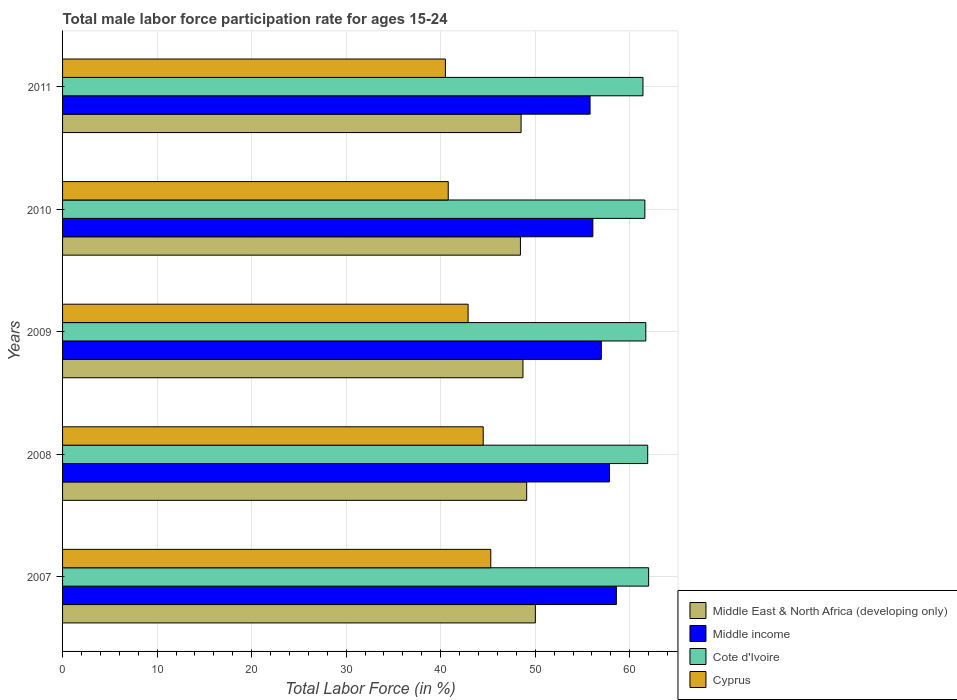Are the number of bars per tick equal to the number of legend labels?
Your answer should be compact. Yes. How many bars are there on the 5th tick from the top?
Give a very brief answer. 4. How many bars are there on the 1st tick from the bottom?
Keep it short and to the point. 4. What is the label of the 5th group of bars from the top?
Make the answer very short. 2007. What is the male labor force participation rate in Cote d'Ivoire in 2008?
Provide a succinct answer. 61.9. Across all years, what is the maximum male labor force participation rate in Middle income?
Ensure brevity in your answer.  58.58. Across all years, what is the minimum male labor force participation rate in Middle income?
Your answer should be compact. 55.8. What is the total male labor force participation rate in Cote d'Ivoire in the graph?
Your answer should be compact. 308.6. What is the difference between the male labor force participation rate in Cyprus in 2009 and that in 2010?
Offer a terse response. 2.1. What is the difference between the male labor force participation rate in Cote d'Ivoire in 2009 and the male labor force participation rate in Cyprus in 2007?
Make the answer very short. 16.4. What is the average male labor force participation rate in Cote d'Ivoire per year?
Your answer should be compact. 61.72. In the year 2007, what is the difference between the male labor force participation rate in Middle East & North Africa (developing only) and male labor force participation rate in Cyprus?
Provide a short and direct response. 4.72. In how many years, is the male labor force participation rate in Cyprus greater than 32 %?
Your response must be concise. 5. What is the ratio of the male labor force participation rate in Cote d'Ivoire in 2007 to that in 2009?
Ensure brevity in your answer.  1. Is the male labor force participation rate in Cyprus in 2007 less than that in 2011?
Offer a terse response. No. What is the difference between the highest and the second highest male labor force participation rate in Cyprus?
Offer a very short reply. 0.8. What is the difference between the highest and the lowest male labor force participation rate in Middle income?
Your response must be concise. 2.78. In how many years, is the male labor force participation rate in Cyprus greater than the average male labor force participation rate in Cyprus taken over all years?
Provide a succinct answer. 3. What does the 4th bar from the top in 2007 represents?
Ensure brevity in your answer.  Middle East & North Africa (developing only). What does the 2nd bar from the bottom in 2010 represents?
Give a very brief answer. Middle income. How many bars are there?
Your answer should be very brief. 20. Are all the bars in the graph horizontal?
Ensure brevity in your answer.  Yes. How many years are there in the graph?
Offer a very short reply. 5. What is the difference between two consecutive major ticks on the X-axis?
Make the answer very short. 10. Where does the legend appear in the graph?
Your answer should be very brief. Bottom right. How are the legend labels stacked?
Your answer should be very brief. Vertical. What is the title of the graph?
Ensure brevity in your answer.  Total male labor force participation rate for ages 15-24. Does "Romania" appear as one of the legend labels in the graph?
Offer a terse response. No. What is the label or title of the X-axis?
Ensure brevity in your answer.  Total Labor Force (in %). What is the label or title of the Y-axis?
Provide a succinct answer. Years. What is the Total Labor Force (in %) of Middle East & North Africa (developing only) in 2007?
Make the answer very short. 50.02. What is the Total Labor Force (in %) in Middle income in 2007?
Provide a short and direct response. 58.58. What is the Total Labor Force (in %) in Cote d'Ivoire in 2007?
Your answer should be compact. 62. What is the Total Labor Force (in %) of Cyprus in 2007?
Provide a succinct answer. 45.3. What is the Total Labor Force (in %) of Middle East & North Africa (developing only) in 2008?
Your response must be concise. 49.1. What is the Total Labor Force (in %) in Middle income in 2008?
Offer a terse response. 57.85. What is the Total Labor Force (in %) in Cote d'Ivoire in 2008?
Your response must be concise. 61.9. What is the Total Labor Force (in %) of Cyprus in 2008?
Your response must be concise. 44.5. What is the Total Labor Force (in %) of Middle East & North Africa (developing only) in 2009?
Give a very brief answer. 48.7. What is the Total Labor Force (in %) of Middle income in 2009?
Ensure brevity in your answer.  56.99. What is the Total Labor Force (in %) in Cote d'Ivoire in 2009?
Provide a short and direct response. 61.7. What is the Total Labor Force (in %) in Cyprus in 2009?
Provide a short and direct response. 42.9. What is the Total Labor Force (in %) in Middle East & North Africa (developing only) in 2010?
Keep it short and to the point. 48.44. What is the Total Labor Force (in %) of Middle income in 2010?
Provide a succinct answer. 56.1. What is the Total Labor Force (in %) of Cote d'Ivoire in 2010?
Your answer should be compact. 61.6. What is the Total Labor Force (in %) of Cyprus in 2010?
Provide a succinct answer. 40.8. What is the Total Labor Force (in %) in Middle East & North Africa (developing only) in 2011?
Make the answer very short. 48.51. What is the Total Labor Force (in %) in Middle income in 2011?
Your answer should be compact. 55.8. What is the Total Labor Force (in %) in Cote d'Ivoire in 2011?
Give a very brief answer. 61.4. What is the Total Labor Force (in %) of Cyprus in 2011?
Provide a short and direct response. 40.5. Across all years, what is the maximum Total Labor Force (in %) of Middle East & North Africa (developing only)?
Keep it short and to the point. 50.02. Across all years, what is the maximum Total Labor Force (in %) of Middle income?
Your response must be concise. 58.58. Across all years, what is the maximum Total Labor Force (in %) in Cyprus?
Provide a succinct answer. 45.3. Across all years, what is the minimum Total Labor Force (in %) of Middle East & North Africa (developing only)?
Ensure brevity in your answer.  48.44. Across all years, what is the minimum Total Labor Force (in %) of Middle income?
Make the answer very short. 55.8. Across all years, what is the minimum Total Labor Force (in %) of Cote d'Ivoire?
Offer a very short reply. 61.4. Across all years, what is the minimum Total Labor Force (in %) in Cyprus?
Your answer should be compact. 40.5. What is the total Total Labor Force (in %) of Middle East & North Africa (developing only) in the graph?
Offer a very short reply. 244.76. What is the total Total Labor Force (in %) of Middle income in the graph?
Ensure brevity in your answer.  285.32. What is the total Total Labor Force (in %) of Cote d'Ivoire in the graph?
Keep it short and to the point. 308.6. What is the total Total Labor Force (in %) in Cyprus in the graph?
Provide a succinct answer. 214. What is the difference between the Total Labor Force (in %) of Middle income in 2007 and that in 2008?
Your response must be concise. 0.74. What is the difference between the Total Labor Force (in %) in Middle East & North Africa (developing only) in 2007 and that in 2009?
Provide a short and direct response. 1.31. What is the difference between the Total Labor Force (in %) of Middle income in 2007 and that in 2009?
Offer a terse response. 1.59. What is the difference between the Total Labor Force (in %) in Cote d'Ivoire in 2007 and that in 2009?
Your answer should be compact. 0.3. What is the difference between the Total Labor Force (in %) of Middle East & North Africa (developing only) in 2007 and that in 2010?
Make the answer very short. 1.58. What is the difference between the Total Labor Force (in %) of Middle income in 2007 and that in 2010?
Ensure brevity in your answer.  2.49. What is the difference between the Total Labor Force (in %) of Middle East & North Africa (developing only) in 2007 and that in 2011?
Provide a succinct answer. 1.51. What is the difference between the Total Labor Force (in %) of Middle income in 2007 and that in 2011?
Make the answer very short. 2.78. What is the difference between the Total Labor Force (in %) of Cote d'Ivoire in 2007 and that in 2011?
Offer a terse response. 0.6. What is the difference between the Total Labor Force (in %) in Cyprus in 2007 and that in 2011?
Give a very brief answer. 4.8. What is the difference between the Total Labor Force (in %) in Middle East & North Africa (developing only) in 2008 and that in 2009?
Offer a terse response. 0.4. What is the difference between the Total Labor Force (in %) of Middle income in 2008 and that in 2009?
Provide a short and direct response. 0.85. What is the difference between the Total Labor Force (in %) in Middle East & North Africa (developing only) in 2008 and that in 2010?
Provide a short and direct response. 0.66. What is the difference between the Total Labor Force (in %) of Middle income in 2008 and that in 2010?
Offer a terse response. 1.75. What is the difference between the Total Labor Force (in %) in Cote d'Ivoire in 2008 and that in 2010?
Your answer should be very brief. 0.3. What is the difference between the Total Labor Force (in %) of Cyprus in 2008 and that in 2010?
Your response must be concise. 3.7. What is the difference between the Total Labor Force (in %) of Middle East & North Africa (developing only) in 2008 and that in 2011?
Your answer should be compact. 0.59. What is the difference between the Total Labor Force (in %) of Middle income in 2008 and that in 2011?
Your answer should be compact. 2.04. What is the difference between the Total Labor Force (in %) of Cyprus in 2008 and that in 2011?
Ensure brevity in your answer.  4. What is the difference between the Total Labor Force (in %) of Middle East & North Africa (developing only) in 2009 and that in 2010?
Give a very brief answer. 0.27. What is the difference between the Total Labor Force (in %) of Middle income in 2009 and that in 2010?
Provide a short and direct response. 0.89. What is the difference between the Total Labor Force (in %) of Cote d'Ivoire in 2009 and that in 2010?
Make the answer very short. 0.1. What is the difference between the Total Labor Force (in %) of Cyprus in 2009 and that in 2010?
Provide a short and direct response. 2.1. What is the difference between the Total Labor Force (in %) in Middle East & North Africa (developing only) in 2009 and that in 2011?
Ensure brevity in your answer.  0.2. What is the difference between the Total Labor Force (in %) in Middle income in 2009 and that in 2011?
Give a very brief answer. 1.19. What is the difference between the Total Labor Force (in %) in Cyprus in 2009 and that in 2011?
Your answer should be very brief. 2.4. What is the difference between the Total Labor Force (in %) in Middle East & North Africa (developing only) in 2010 and that in 2011?
Your answer should be compact. -0.07. What is the difference between the Total Labor Force (in %) in Middle income in 2010 and that in 2011?
Provide a succinct answer. 0.3. What is the difference between the Total Labor Force (in %) of Middle East & North Africa (developing only) in 2007 and the Total Labor Force (in %) of Middle income in 2008?
Offer a terse response. -7.83. What is the difference between the Total Labor Force (in %) of Middle East & North Africa (developing only) in 2007 and the Total Labor Force (in %) of Cote d'Ivoire in 2008?
Ensure brevity in your answer.  -11.88. What is the difference between the Total Labor Force (in %) of Middle East & North Africa (developing only) in 2007 and the Total Labor Force (in %) of Cyprus in 2008?
Provide a short and direct response. 5.52. What is the difference between the Total Labor Force (in %) of Middle income in 2007 and the Total Labor Force (in %) of Cote d'Ivoire in 2008?
Offer a terse response. -3.32. What is the difference between the Total Labor Force (in %) of Middle income in 2007 and the Total Labor Force (in %) of Cyprus in 2008?
Ensure brevity in your answer.  14.08. What is the difference between the Total Labor Force (in %) in Middle East & North Africa (developing only) in 2007 and the Total Labor Force (in %) in Middle income in 2009?
Offer a terse response. -6.98. What is the difference between the Total Labor Force (in %) of Middle East & North Africa (developing only) in 2007 and the Total Labor Force (in %) of Cote d'Ivoire in 2009?
Give a very brief answer. -11.68. What is the difference between the Total Labor Force (in %) of Middle East & North Africa (developing only) in 2007 and the Total Labor Force (in %) of Cyprus in 2009?
Your response must be concise. 7.12. What is the difference between the Total Labor Force (in %) in Middle income in 2007 and the Total Labor Force (in %) in Cote d'Ivoire in 2009?
Keep it short and to the point. -3.12. What is the difference between the Total Labor Force (in %) in Middle income in 2007 and the Total Labor Force (in %) in Cyprus in 2009?
Your answer should be very brief. 15.68. What is the difference between the Total Labor Force (in %) of Cote d'Ivoire in 2007 and the Total Labor Force (in %) of Cyprus in 2009?
Provide a short and direct response. 19.1. What is the difference between the Total Labor Force (in %) in Middle East & North Africa (developing only) in 2007 and the Total Labor Force (in %) in Middle income in 2010?
Make the answer very short. -6.08. What is the difference between the Total Labor Force (in %) of Middle East & North Africa (developing only) in 2007 and the Total Labor Force (in %) of Cote d'Ivoire in 2010?
Provide a succinct answer. -11.58. What is the difference between the Total Labor Force (in %) of Middle East & North Africa (developing only) in 2007 and the Total Labor Force (in %) of Cyprus in 2010?
Offer a terse response. 9.22. What is the difference between the Total Labor Force (in %) of Middle income in 2007 and the Total Labor Force (in %) of Cote d'Ivoire in 2010?
Offer a terse response. -3.02. What is the difference between the Total Labor Force (in %) of Middle income in 2007 and the Total Labor Force (in %) of Cyprus in 2010?
Provide a short and direct response. 17.78. What is the difference between the Total Labor Force (in %) in Cote d'Ivoire in 2007 and the Total Labor Force (in %) in Cyprus in 2010?
Give a very brief answer. 21.2. What is the difference between the Total Labor Force (in %) in Middle East & North Africa (developing only) in 2007 and the Total Labor Force (in %) in Middle income in 2011?
Provide a succinct answer. -5.79. What is the difference between the Total Labor Force (in %) in Middle East & North Africa (developing only) in 2007 and the Total Labor Force (in %) in Cote d'Ivoire in 2011?
Your answer should be compact. -11.38. What is the difference between the Total Labor Force (in %) of Middle East & North Africa (developing only) in 2007 and the Total Labor Force (in %) of Cyprus in 2011?
Give a very brief answer. 9.52. What is the difference between the Total Labor Force (in %) in Middle income in 2007 and the Total Labor Force (in %) in Cote d'Ivoire in 2011?
Your answer should be very brief. -2.82. What is the difference between the Total Labor Force (in %) in Middle income in 2007 and the Total Labor Force (in %) in Cyprus in 2011?
Provide a short and direct response. 18.08. What is the difference between the Total Labor Force (in %) of Middle East & North Africa (developing only) in 2008 and the Total Labor Force (in %) of Middle income in 2009?
Provide a succinct answer. -7.89. What is the difference between the Total Labor Force (in %) in Middle East & North Africa (developing only) in 2008 and the Total Labor Force (in %) in Cote d'Ivoire in 2009?
Offer a very short reply. -12.6. What is the difference between the Total Labor Force (in %) of Middle East & North Africa (developing only) in 2008 and the Total Labor Force (in %) of Cyprus in 2009?
Provide a succinct answer. 6.2. What is the difference between the Total Labor Force (in %) in Middle income in 2008 and the Total Labor Force (in %) in Cote d'Ivoire in 2009?
Provide a succinct answer. -3.85. What is the difference between the Total Labor Force (in %) of Middle income in 2008 and the Total Labor Force (in %) of Cyprus in 2009?
Your answer should be very brief. 14.95. What is the difference between the Total Labor Force (in %) in Middle East & North Africa (developing only) in 2008 and the Total Labor Force (in %) in Middle income in 2010?
Offer a very short reply. -7. What is the difference between the Total Labor Force (in %) of Middle East & North Africa (developing only) in 2008 and the Total Labor Force (in %) of Cote d'Ivoire in 2010?
Offer a very short reply. -12.5. What is the difference between the Total Labor Force (in %) in Middle East & North Africa (developing only) in 2008 and the Total Labor Force (in %) in Cyprus in 2010?
Offer a very short reply. 8.3. What is the difference between the Total Labor Force (in %) in Middle income in 2008 and the Total Labor Force (in %) in Cote d'Ivoire in 2010?
Ensure brevity in your answer.  -3.75. What is the difference between the Total Labor Force (in %) in Middle income in 2008 and the Total Labor Force (in %) in Cyprus in 2010?
Your response must be concise. 17.05. What is the difference between the Total Labor Force (in %) in Cote d'Ivoire in 2008 and the Total Labor Force (in %) in Cyprus in 2010?
Provide a short and direct response. 21.1. What is the difference between the Total Labor Force (in %) of Middle East & North Africa (developing only) in 2008 and the Total Labor Force (in %) of Middle income in 2011?
Offer a terse response. -6.7. What is the difference between the Total Labor Force (in %) of Middle East & North Africa (developing only) in 2008 and the Total Labor Force (in %) of Cote d'Ivoire in 2011?
Offer a very short reply. -12.3. What is the difference between the Total Labor Force (in %) of Middle East & North Africa (developing only) in 2008 and the Total Labor Force (in %) of Cyprus in 2011?
Your answer should be very brief. 8.6. What is the difference between the Total Labor Force (in %) in Middle income in 2008 and the Total Labor Force (in %) in Cote d'Ivoire in 2011?
Your answer should be compact. -3.55. What is the difference between the Total Labor Force (in %) of Middle income in 2008 and the Total Labor Force (in %) of Cyprus in 2011?
Keep it short and to the point. 17.35. What is the difference between the Total Labor Force (in %) in Cote d'Ivoire in 2008 and the Total Labor Force (in %) in Cyprus in 2011?
Your answer should be compact. 21.4. What is the difference between the Total Labor Force (in %) in Middle East & North Africa (developing only) in 2009 and the Total Labor Force (in %) in Middle income in 2010?
Keep it short and to the point. -7.4. What is the difference between the Total Labor Force (in %) in Middle East & North Africa (developing only) in 2009 and the Total Labor Force (in %) in Cote d'Ivoire in 2010?
Keep it short and to the point. -12.9. What is the difference between the Total Labor Force (in %) of Middle East & North Africa (developing only) in 2009 and the Total Labor Force (in %) of Cyprus in 2010?
Your answer should be compact. 7.9. What is the difference between the Total Labor Force (in %) of Middle income in 2009 and the Total Labor Force (in %) of Cote d'Ivoire in 2010?
Your response must be concise. -4.61. What is the difference between the Total Labor Force (in %) in Middle income in 2009 and the Total Labor Force (in %) in Cyprus in 2010?
Make the answer very short. 16.19. What is the difference between the Total Labor Force (in %) of Cote d'Ivoire in 2009 and the Total Labor Force (in %) of Cyprus in 2010?
Offer a terse response. 20.9. What is the difference between the Total Labor Force (in %) in Middle East & North Africa (developing only) in 2009 and the Total Labor Force (in %) in Middle income in 2011?
Provide a succinct answer. -7.1. What is the difference between the Total Labor Force (in %) of Middle East & North Africa (developing only) in 2009 and the Total Labor Force (in %) of Cote d'Ivoire in 2011?
Give a very brief answer. -12.7. What is the difference between the Total Labor Force (in %) in Middle East & North Africa (developing only) in 2009 and the Total Labor Force (in %) in Cyprus in 2011?
Your answer should be very brief. 8.2. What is the difference between the Total Labor Force (in %) of Middle income in 2009 and the Total Labor Force (in %) of Cote d'Ivoire in 2011?
Ensure brevity in your answer.  -4.41. What is the difference between the Total Labor Force (in %) in Middle income in 2009 and the Total Labor Force (in %) in Cyprus in 2011?
Offer a very short reply. 16.49. What is the difference between the Total Labor Force (in %) of Cote d'Ivoire in 2009 and the Total Labor Force (in %) of Cyprus in 2011?
Offer a very short reply. 21.2. What is the difference between the Total Labor Force (in %) of Middle East & North Africa (developing only) in 2010 and the Total Labor Force (in %) of Middle income in 2011?
Offer a very short reply. -7.36. What is the difference between the Total Labor Force (in %) in Middle East & North Africa (developing only) in 2010 and the Total Labor Force (in %) in Cote d'Ivoire in 2011?
Offer a terse response. -12.96. What is the difference between the Total Labor Force (in %) of Middle East & North Africa (developing only) in 2010 and the Total Labor Force (in %) of Cyprus in 2011?
Offer a very short reply. 7.94. What is the difference between the Total Labor Force (in %) of Middle income in 2010 and the Total Labor Force (in %) of Cote d'Ivoire in 2011?
Offer a very short reply. -5.3. What is the difference between the Total Labor Force (in %) of Middle income in 2010 and the Total Labor Force (in %) of Cyprus in 2011?
Provide a short and direct response. 15.6. What is the difference between the Total Labor Force (in %) of Cote d'Ivoire in 2010 and the Total Labor Force (in %) of Cyprus in 2011?
Provide a succinct answer. 21.1. What is the average Total Labor Force (in %) in Middle East & North Africa (developing only) per year?
Keep it short and to the point. 48.95. What is the average Total Labor Force (in %) of Middle income per year?
Your answer should be very brief. 57.06. What is the average Total Labor Force (in %) in Cote d'Ivoire per year?
Offer a very short reply. 61.72. What is the average Total Labor Force (in %) of Cyprus per year?
Your response must be concise. 42.8. In the year 2007, what is the difference between the Total Labor Force (in %) in Middle East & North Africa (developing only) and Total Labor Force (in %) in Middle income?
Your response must be concise. -8.57. In the year 2007, what is the difference between the Total Labor Force (in %) in Middle East & North Africa (developing only) and Total Labor Force (in %) in Cote d'Ivoire?
Your answer should be compact. -11.98. In the year 2007, what is the difference between the Total Labor Force (in %) of Middle East & North Africa (developing only) and Total Labor Force (in %) of Cyprus?
Give a very brief answer. 4.72. In the year 2007, what is the difference between the Total Labor Force (in %) in Middle income and Total Labor Force (in %) in Cote d'Ivoire?
Provide a short and direct response. -3.42. In the year 2007, what is the difference between the Total Labor Force (in %) in Middle income and Total Labor Force (in %) in Cyprus?
Offer a very short reply. 13.28. In the year 2008, what is the difference between the Total Labor Force (in %) in Middle East & North Africa (developing only) and Total Labor Force (in %) in Middle income?
Offer a terse response. -8.75. In the year 2008, what is the difference between the Total Labor Force (in %) in Middle East & North Africa (developing only) and Total Labor Force (in %) in Cote d'Ivoire?
Keep it short and to the point. -12.8. In the year 2008, what is the difference between the Total Labor Force (in %) in Middle East & North Africa (developing only) and Total Labor Force (in %) in Cyprus?
Keep it short and to the point. 4.6. In the year 2008, what is the difference between the Total Labor Force (in %) in Middle income and Total Labor Force (in %) in Cote d'Ivoire?
Provide a short and direct response. -4.05. In the year 2008, what is the difference between the Total Labor Force (in %) of Middle income and Total Labor Force (in %) of Cyprus?
Provide a succinct answer. 13.35. In the year 2008, what is the difference between the Total Labor Force (in %) in Cote d'Ivoire and Total Labor Force (in %) in Cyprus?
Your answer should be very brief. 17.4. In the year 2009, what is the difference between the Total Labor Force (in %) of Middle East & North Africa (developing only) and Total Labor Force (in %) of Middle income?
Offer a very short reply. -8.29. In the year 2009, what is the difference between the Total Labor Force (in %) in Middle East & North Africa (developing only) and Total Labor Force (in %) in Cote d'Ivoire?
Ensure brevity in your answer.  -13. In the year 2009, what is the difference between the Total Labor Force (in %) of Middle East & North Africa (developing only) and Total Labor Force (in %) of Cyprus?
Provide a succinct answer. 5.8. In the year 2009, what is the difference between the Total Labor Force (in %) in Middle income and Total Labor Force (in %) in Cote d'Ivoire?
Make the answer very short. -4.71. In the year 2009, what is the difference between the Total Labor Force (in %) of Middle income and Total Labor Force (in %) of Cyprus?
Ensure brevity in your answer.  14.09. In the year 2010, what is the difference between the Total Labor Force (in %) of Middle East & North Africa (developing only) and Total Labor Force (in %) of Middle income?
Provide a short and direct response. -7.66. In the year 2010, what is the difference between the Total Labor Force (in %) in Middle East & North Africa (developing only) and Total Labor Force (in %) in Cote d'Ivoire?
Give a very brief answer. -13.16. In the year 2010, what is the difference between the Total Labor Force (in %) in Middle East & North Africa (developing only) and Total Labor Force (in %) in Cyprus?
Your answer should be very brief. 7.64. In the year 2010, what is the difference between the Total Labor Force (in %) in Middle income and Total Labor Force (in %) in Cote d'Ivoire?
Keep it short and to the point. -5.5. In the year 2010, what is the difference between the Total Labor Force (in %) of Middle income and Total Labor Force (in %) of Cyprus?
Provide a short and direct response. 15.3. In the year 2010, what is the difference between the Total Labor Force (in %) of Cote d'Ivoire and Total Labor Force (in %) of Cyprus?
Keep it short and to the point. 20.8. In the year 2011, what is the difference between the Total Labor Force (in %) in Middle East & North Africa (developing only) and Total Labor Force (in %) in Middle income?
Make the answer very short. -7.3. In the year 2011, what is the difference between the Total Labor Force (in %) of Middle East & North Africa (developing only) and Total Labor Force (in %) of Cote d'Ivoire?
Make the answer very short. -12.89. In the year 2011, what is the difference between the Total Labor Force (in %) of Middle East & North Africa (developing only) and Total Labor Force (in %) of Cyprus?
Give a very brief answer. 8.01. In the year 2011, what is the difference between the Total Labor Force (in %) in Middle income and Total Labor Force (in %) in Cote d'Ivoire?
Your answer should be very brief. -5.6. In the year 2011, what is the difference between the Total Labor Force (in %) of Middle income and Total Labor Force (in %) of Cyprus?
Offer a terse response. 15.3. In the year 2011, what is the difference between the Total Labor Force (in %) in Cote d'Ivoire and Total Labor Force (in %) in Cyprus?
Provide a short and direct response. 20.9. What is the ratio of the Total Labor Force (in %) of Middle East & North Africa (developing only) in 2007 to that in 2008?
Keep it short and to the point. 1.02. What is the ratio of the Total Labor Force (in %) of Middle income in 2007 to that in 2008?
Give a very brief answer. 1.01. What is the ratio of the Total Labor Force (in %) of Cote d'Ivoire in 2007 to that in 2008?
Your response must be concise. 1. What is the ratio of the Total Labor Force (in %) in Cyprus in 2007 to that in 2008?
Your response must be concise. 1.02. What is the ratio of the Total Labor Force (in %) of Middle income in 2007 to that in 2009?
Give a very brief answer. 1.03. What is the ratio of the Total Labor Force (in %) in Cyprus in 2007 to that in 2009?
Offer a terse response. 1.06. What is the ratio of the Total Labor Force (in %) of Middle East & North Africa (developing only) in 2007 to that in 2010?
Your response must be concise. 1.03. What is the ratio of the Total Labor Force (in %) in Middle income in 2007 to that in 2010?
Your answer should be very brief. 1.04. What is the ratio of the Total Labor Force (in %) of Cyprus in 2007 to that in 2010?
Your answer should be very brief. 1.11. What is the ratio of the Total Labor Force (in %) in Middle East & North Africa (developing only) in 2007 to that in 2011?
Offer a very short reply. 1.03. What is the ratio of the Total Labor Force (in %) in Middle income in 2007 to that in 2011?
Offer a very short reply. 1.05. What is the ratio of the Total Labor Force (in %) in Cote d'Ivoire in 2007 to that in 2011?
Provide a succinct answer. 1.01. What is the ratio of the Total Labor Force (in %) in Cyprus in 2007 to that in 2011?
Your response must be concise. 1.12. What is the ratio of the Total Labor Force (in %) in Cote d'Ivoire in 2008 to that in 2009?
Your answer should be very brief. 1. What is the ratio of the Total Labor Force (in %) in Cyprus in 2008 to that in 2009?
Provide a short and direct response. 1.04. What is the ratio of the Total Labor Force (in %) of Middle East & North Africa (developing only) in 2008 to that in 2010?
Your response must be concise. 1.01. What is the ratio of the Total Labor Force (in %) in Middle income in 2008 to that in 2010?
Your response must be concise. 1.03. What is the ratio of the Total Labor Force (in %) of Cote d'Ivoire in 2008 to that in 2010?
Your answer should be very brief. 1. What is the ratio of the Total Labor Force (in %) in Cyprus in 2008 to that in 2010?
Make the answer very short. 1.09. What is the ratio of the Total Labor Force (in %) in Middle East & North Africa (developing only) in 2008 to that in 2011?
Your response must be concise. 1.01. What is the ratio of the Total Labor Force (in %) of Middle income in 2008 to that in 2011?
Your answer should be very brief. 1.04. What is the ratio of the Total Labor Force (in %) of Cyprus in 2008 to that in 2011?
Offer a very short reply. 1.1. What is the ratio of the Total Labor Force (in %) of Middle East & North Africa (developing only) in 2009 to that in 2010?
Give a very brief answer. 1.01. What is the ratio of the Total Labor Force (in %) in Middle income in 2009 to that in 2010?
Your answer should be very brief. 1.02. What is the ratio of the Total Labor Force (in %) of Cote d'Ivoire in 2009 to that in 2010?
Ensure brevity in your answer.  1. What is the ratio of the Total Labor Force (in %) in Cyprus in 2009 to that in 2010?
Offer a very short reply. 1.05. What is the ratio of the Total Labor Force (in %) in Middle East & North Africa (developing only) in 2009 to that in 2011?
Provide a short and direct response. 1. What is the ratio of the Total Labor Force (in %) of Middle income in 2009 to that in 2011?
Provide a short and direct response. 1.02. What is the ratio of the Total Labor Force (in %) of Cote d'Ivoire in 2009 to that in 2011?
Offer a very short reply. 1. What is the ratio of the Total Labor Force (in %) of Cyprus in 2009 to that in 2011?
Your answer should be compact. 1.06. What is the ratio of the Total Labor Force (in %) of Middle income in 2010 to that in 2011?
Offer a very short reply. 1.01. What is the ratio of the Total Labor Force (in %) of Cyprus in 2010 to that in 2011?
Provide a short and direct response. 1.01. What is the difference between the highest and the second highest Total Labor Force (in %) in Middle income?
Offer a very short reply. 0.74. What is the difference between the highest and the second highest Total Labor Force (in %) of Cyprus?
Your response must be concise. 0.8. What is the difference between the highest and the lowest Total Labor Force (in %) of Middle East & North Africa (developing only)?
Make the answer very short. 1.58. What is the difference between the highest and the lowest Total Labor Force (in %) of Middle income?
Give a very brief answer. 2.78. What is the difference between the highest and the lowest Total Labor Force (in %) in Cyprus?
Provide a succinct answer. 4.8. 